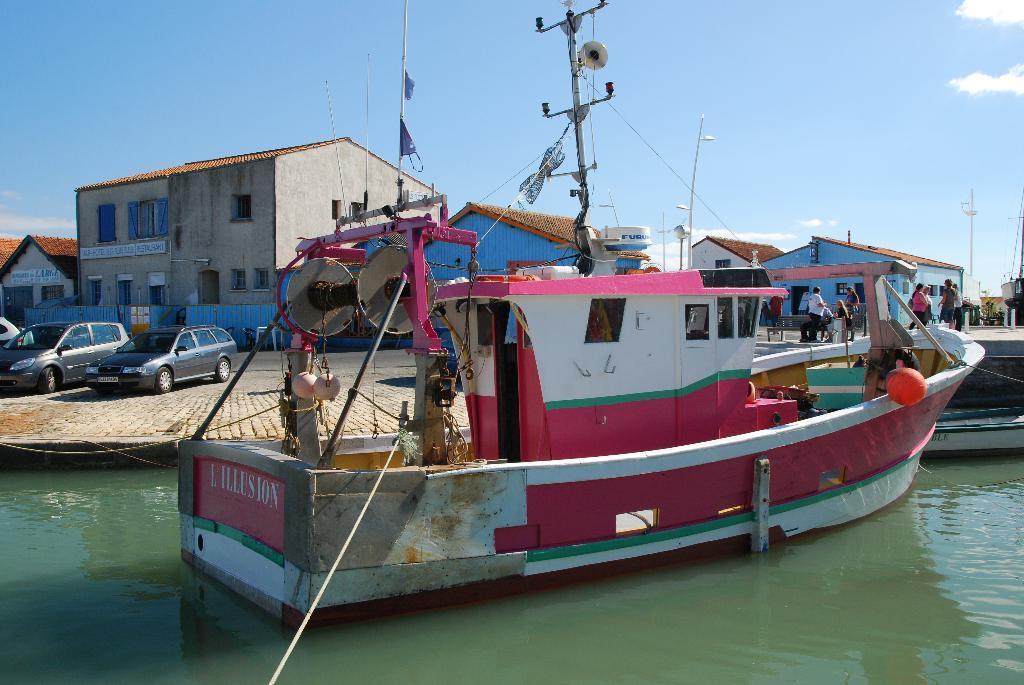Describe this image in one or two sentences. In the center of the image, we can see a boat on the water and in the background, there are buildings, vehicles, benches, poles and some people. At the top, there are clouds in the sky. 